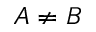Convert formula to latex. <formula><loc_0><loc_0><loc_500><loc_500>A \neq B</formula> 